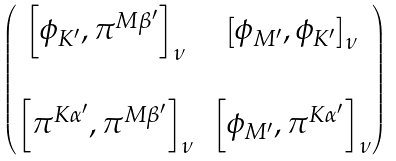Convert formula to latex. <formula><loc_0><loc_0><loc_500><loc_500>\begin{pmatrix} \left [ \phi _ { K ^ { \prime } } , \pi ^ { M \beta ^ { \prime } } \right ] _ { \nu } & \left [ \phi _ { M ^ { \prime } } , \phi _ { K ^ { \prime } } \right ] _ { \nu } \\ \\ \left [ \pi ^ { K \alpha ^ { \prime } } , \pi ^ { M \beta ^ { \prime } } \right ] _ { \nu } & \left [ \phi _ { M ^ { \prime } } , \pi ^ { K \alpha ^ { \prime } } \right ] _ { \nu } \end{pmatrix}</formula> 